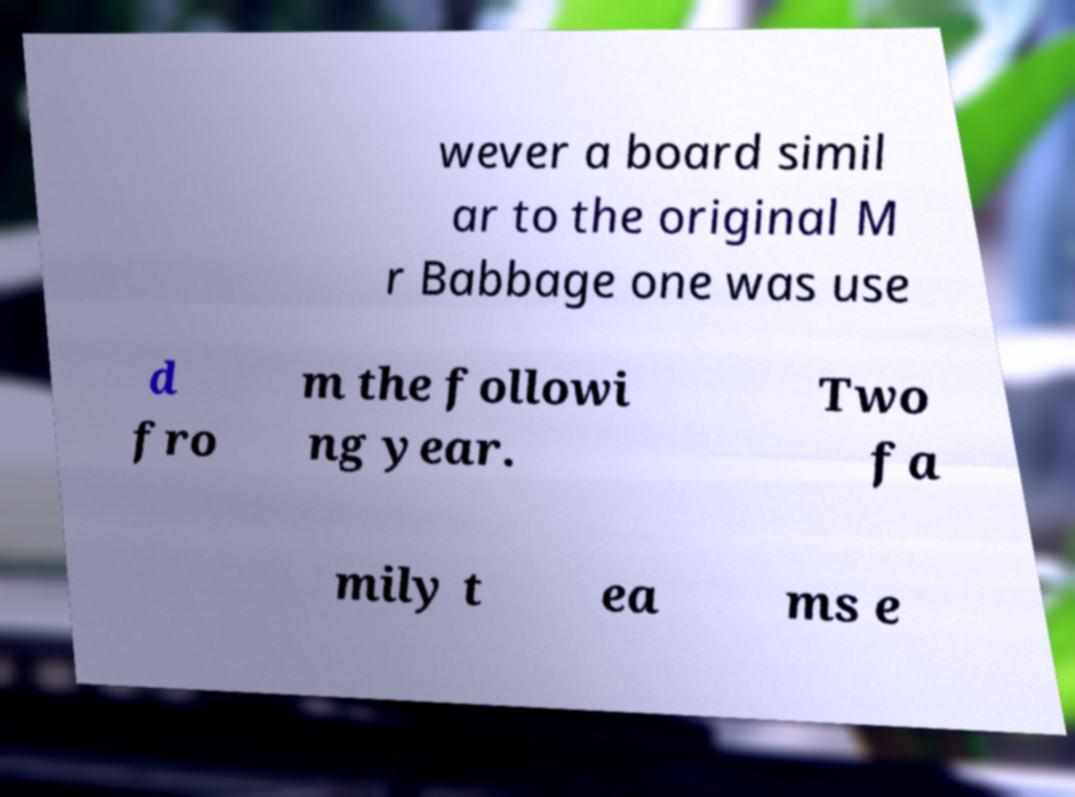For documentation purposes, I need the text within this image transcribed. Could you provide that? wever a board simil ar to the original M r Babbage one was use d fro m the followi ng year. Two fa mily t ea ms e 